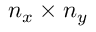<formula> <loc_0><loc_0><loc_500><loc_500>n _ { x } \times n _ { y }</formula> 